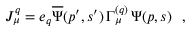Convert formula to latex. <formula><loc_0><loc_0><loc_500><loc_500>J _ { \mu } ^ { q } = e _ { q } { \overline { \Psi } } ( p ^ { \prime } , s ^ { \prime } ) \, \Gamma _ { \mu } ^ { ( q ) } \, \Psi ( p , s ) \ \ ,</formula> 